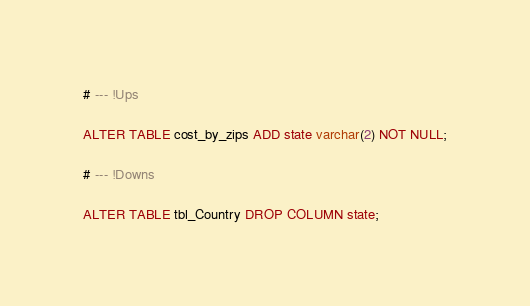<code> <loc_0><loc_0><loc_500><loc_500><_SQL_># --- !Ups

ALTER TABLE cost_by_zips ADD state varchar(2) NOT NULL;

# --- !Downs

ALTER TABLE tbl_Country DROP COLUMN state;</code> 